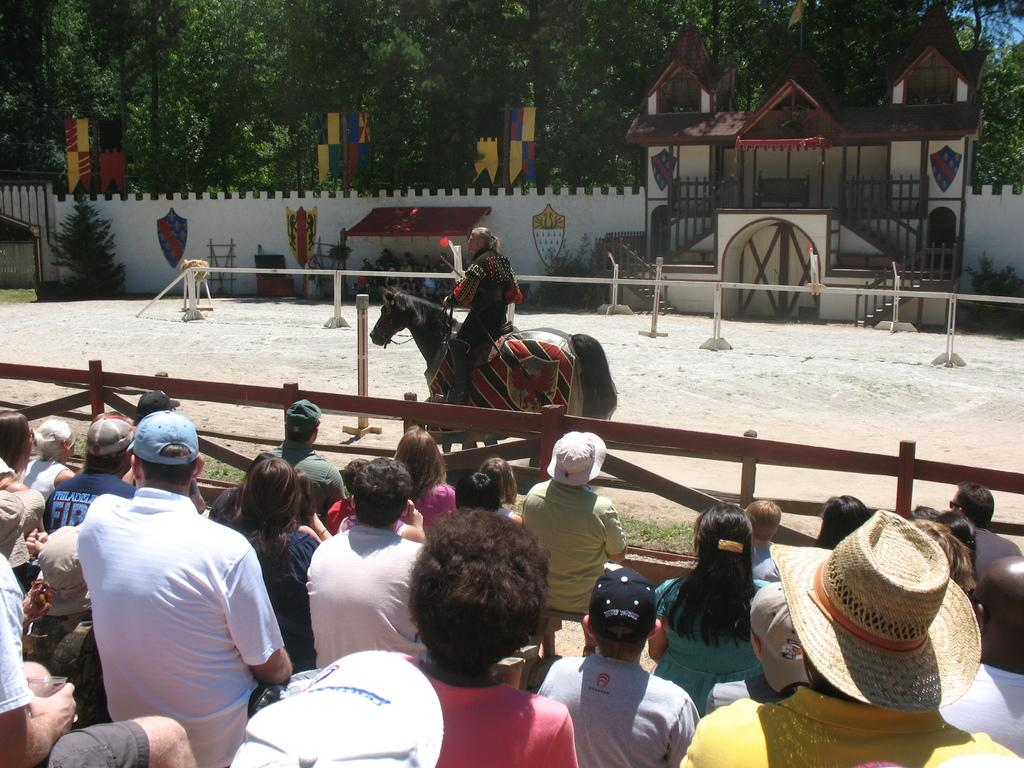What is the main subject of the image? There is a person riding a horse in the image. How are other people reacting to the person riding the horse? People are looking at the person riding the horse. What can be seen in the background of the image? There are trees, a fence, and a small building in the background of the image. What type of toy is the writer using in the image? There is no writer or toy present in the image. How many pigs are visible in the image? There are no pigs visible in the image. 